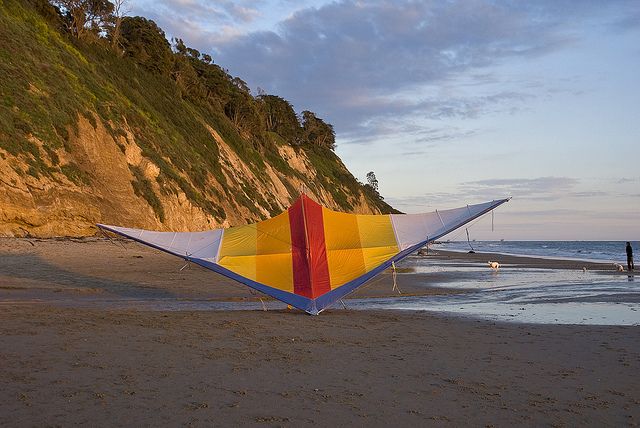<image>What animals are visible? I am not sure which animals are visible. It could be a dog or birds. Why isn't the kite in the air? The precise reason why the kite isn't in the air is unclear. It could be due to lack of wind or the kite is on the beach or the ground. What animals are visible? It can be seen dogs and birds in the image. Why isn't the kite in the air? It is unanswerable why the kite isn't in the air. 